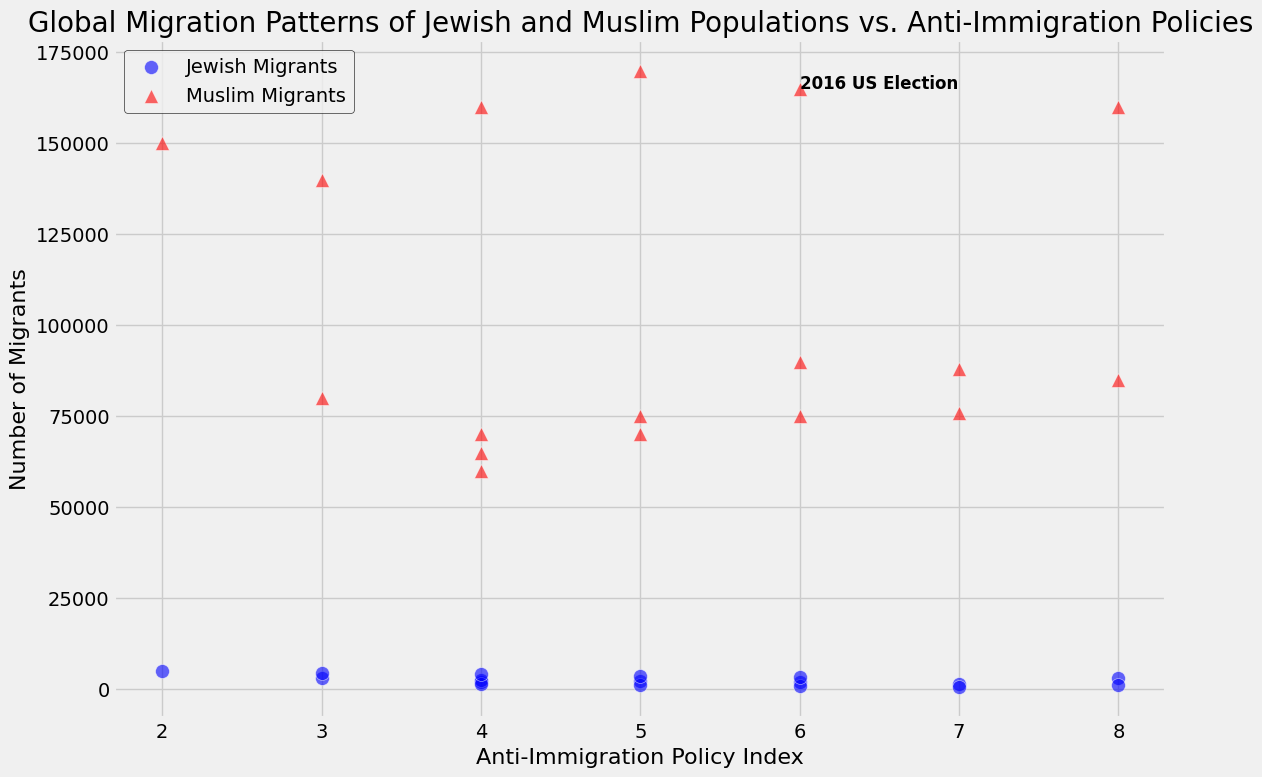How did migration trends for Jewish and Muslim populations in the USA change from 2005 to 2010? From the scatter plot, locate the points for the USA in 2005 and 2010. In 2005, the number of Jewish migrants was 4,500, and Muslim migrants were 140,000. In 2010, these numbers were 4,000 and 160,000 respectively. The number of Jewish migrants decreased by 500, while the number of Muslim migrants increased by 20,000.
Answer: Jewish migrants decreased by 500; Muslim migrants increased by 20,000 Which country had the highest number of Muslim migrants in 2016, and what was the Anti-Immigration Policy Index for that country? Identify the scatter points representing Muslim migrants in 2016. The USA had 165,000 Muslim migrants in 2016, the highest among the countries, with an Anti-Immigration Policy Index of 6.
Answer: USA, 6 What is the relationship between the Anti-Immigration Policy Index and the number of Jewish migrants in Germany in 2010 and 2015? Find the scatter points for Germany in 2010 and 2015 for Jewish migrants. In 2010, Germany had 2,200 Jewish migrants with an index of 5. In 2015, it had 2,000 Jewish migrants with an index of 6. A higher index correlates with a slight decrease in Jewish migrants.
Answer: Higher index correlates with a slight decrease Which country in 2020 had the lowest number of Jewish migrants, and what was its Anti-Immigration Policy Index? Locate the scatter points for Jewish migrants in 2020. Germany had the lowest number of Jewish migrants, with 1,000, and an Anti-Immigration Policy Index of 8.
Answer: Germany, 8 How did the 2016 US Election appear to affect migration trends in the USA for both Jewish and Muslim populations in the subsequent years? Observe the scatter points for the USA before and after 2016. In 2016, the annotations "2016 US Election" coincides with 165,000 Muslim migrants and 3,200 Jewish migrants. By 2020, the numbers slightly decreased to 160,000 Muslim migrants and 3,000 Jewish migrants. Thus, a slight decrease for both populations is observed after the election.
Answer: Slight decrease in both populations Compare the change in the number of Muslim migrants in France from 2005 to 2016 with Germany in the same period. Identifying the 2005 and 2016 points for both countries: France had 65,000 to 76,000 Muslim migrants, a change of 11,000. Germany had 70,000 to 88,000 Muslim migrants, a change of 18,000.
Answer: France: 11,000 increase; Germany: 18,000 increase What trend can be observed in the Anti-Immigration Policy Index for all countries from 2001 to 2020? Checking the Anti-Immigration Policy Index for all years shows that it constantly increased from 2001 to 2020 for the USA, Germany, and France.
Answer: Constant increase What's the proportion of Muslim to Jewish migrants in France in 2015? Locate the respective points for France in 2015: 75,000 Muslim migrants and 800 Jewish migrants. The ratio is 75,000/800, which simplifies to approximately 93.75:1.
Answer: 93.75:1 Between the USA, Germany, and France, which country had the highest increase in the Anti-Immigration Policy Index from 2005 to 2016? Checking the index values from 2005 to 2016: USA from 3 to 6 (increase by 3), Germany from 4 to 7 (increase by 3), France from 4 to 7 (increase by 3). All countries had identical increases.
Answer: Equal increase 